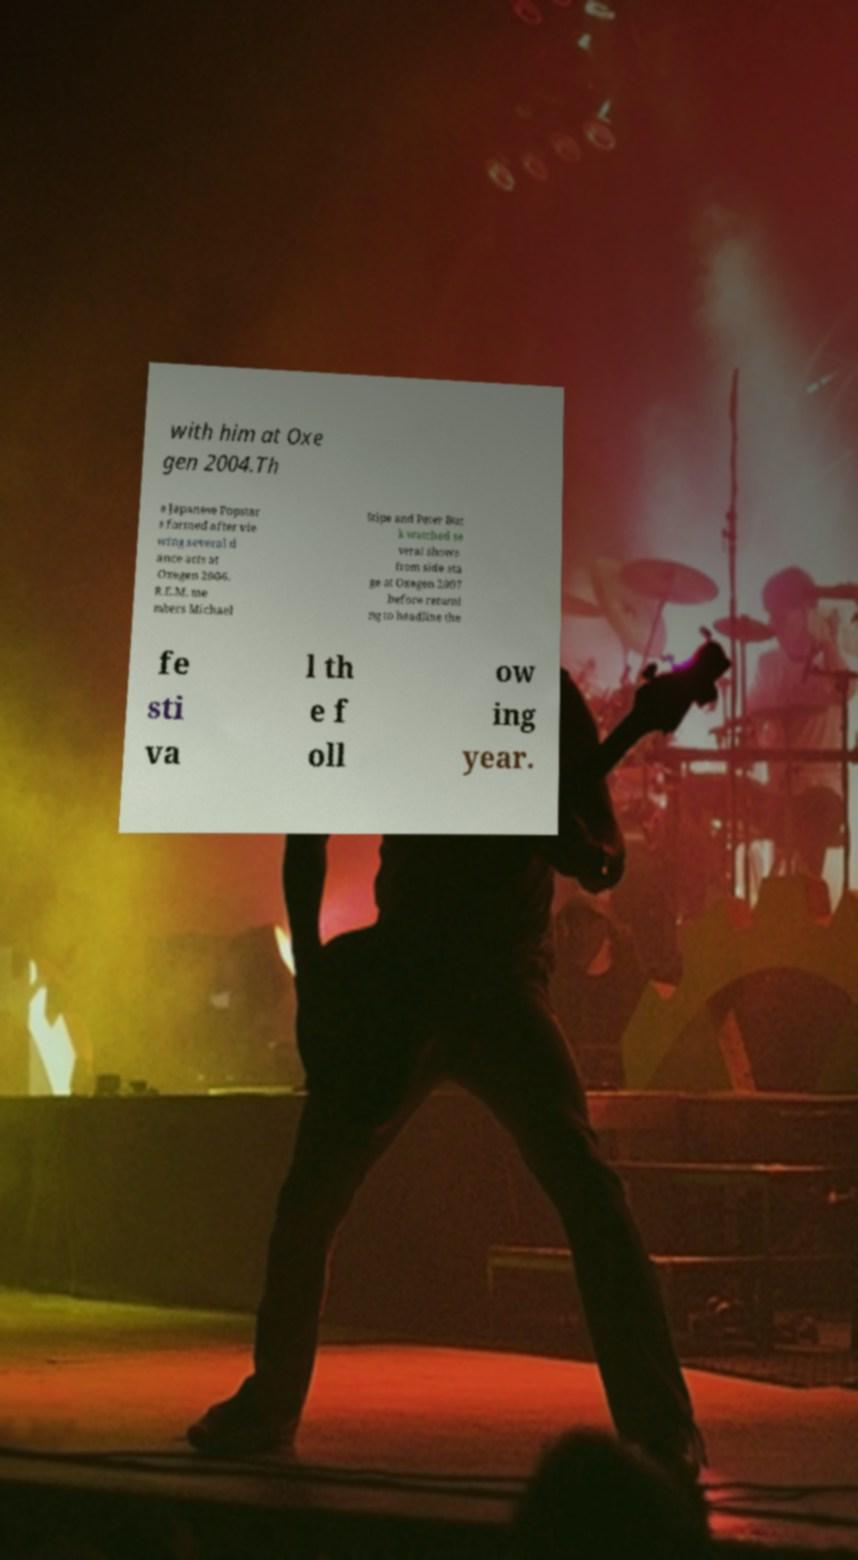For documentation purposes, I need the text within this image transcribed. Could you provide that? with him at Oxe gen 2004.Th e Japanese Popstar s formed after vie wing several d ance acts at Oxegen 2006. R.E.M. me mbers Michael Stipe and Peter Buc k watched se veral shows from side sta ge at Oxegen 2007 before returni ng to headline the fe sti va l th e f oll ow ing year. 